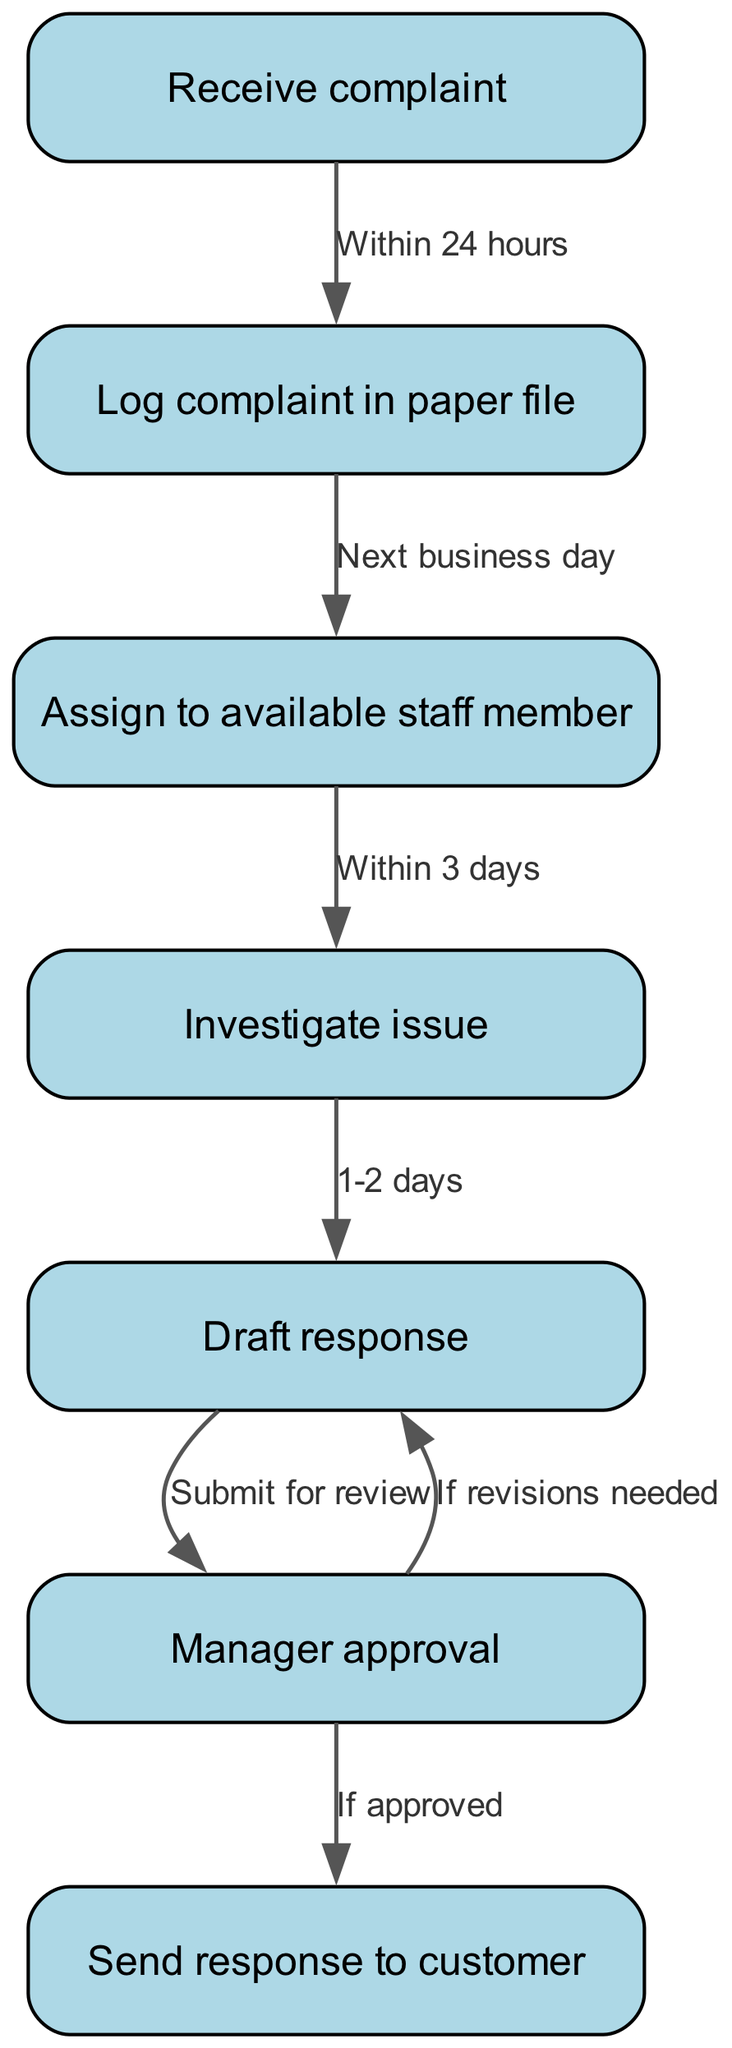What's the first step in the complaint handling process? The diagram starts with the node labeled "Receive complaint," which indicates the beginning of the process.
Answer: Receive complaint How many nodes are there in the diagram? By counting the nodes listed in the data, there are a total of seven nodes that represent different steps in the complaint handling process.
Answer: 7 What is the action taken after "Log complaint in paper file"? The edge leading from "Log complaint in paper file" points to "Assign to available staff member," indicating that this action follows logging the complaint.
Answer: Assign to available staff member What is the time frame for "Investigate issue"? The edge from "Assign to available staff member" to "Investigate issue" states it should be done within three days, which is indicated as the time frame for this step.
Answer: Within 3 days What happens if revisions are needed after drafting the response? The edge from "Manager approval" leads back to "Draft response" and states "If revisions needed," signifying that if the response requires changes, it goes back to the drafting stage.
Answer: Draft response What is the final step in the process? The last node in the flow of the diagram is "Send response to customer," which indicates that this is the final step of the complaint handling process.
Answer: Send response to customer What happens after "Manager approval"? The diagram shows two possible outcomes from "Manager approval": it either leads to "Send response to customer" if approved or goes back to "Draft response" if revisions are needed.
Answer: Send response to customer or Draft response How long does it take to draft a response? The edge from "Investigate issue" to "Draft response" states that this step takes 1-2 days, reflecting the required time frame for this action.
Answer: 1-2 days 